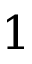<formula> <loc_0><loc_0><loc_500><loc_500>1</formula> 